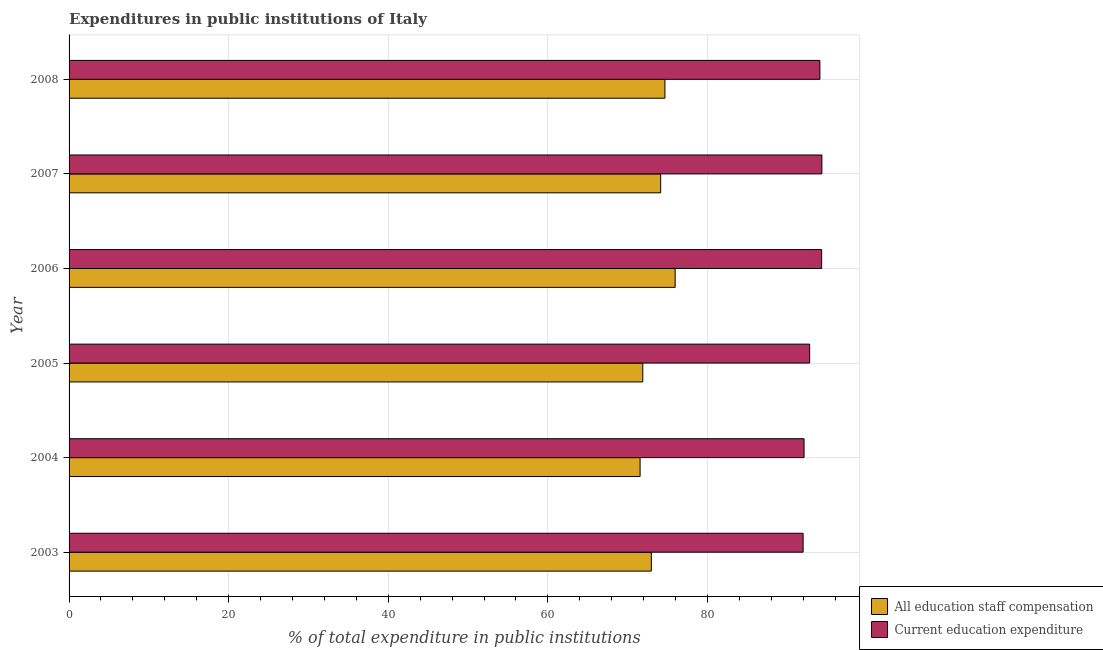How many groups of bars are there?
Offer a very short reply. 6. How many bars are there on the 2nd tick from the top?
Your answer should be very brief. 2. How many bars are there on the 5th tick from the bottom?
Provide a succinct answer. 2. What is the expenditure in education in 2003?
Keep it short and to the point. 91.98. Across all years, what is the maximum expenditure in staff compensation?
Your answer should be very brief. 75.95. Across all years, what is the minimum expenditure in staff compensation?
Your answer should be very brief. 71.56. In which year was the expenditure in education maximum?
Provide a short and direct response. 2007. In which year was the expenditure in staff compensation minimum?
Provide a short and direct response. 2004. What is the total expenditure in staff compensation in the graph?
Your response must be concise. 441.18. What is the difference between the expenditure in staff compensation in 2003 and that in 2004?
Offer a terse response. 1.41. What is the difference between the expenditure in education in 2004 and the expenditure in staff compensation in 2005?
Give a very brief answer. 20.21. What is the average expenditure in education per year?
Offer a very short reply. 93.27. In the year 2006, what is the difference between the expenditure in education and expenditure in staff compensation?
Make the answer very short. 18.36. In how many years, is the expenditure in education greater than 36 %?
Offer a very short reply. 6. What is the ratio of the expenditure in staff compensation in 2005 to that in 2007?
Offer a terse response. 0.97. Is the difference between the expenditure in education in 2004 and 2006 greater than the difference between the expenditure in staff compensation in 2004 and 2006?
Ensure brevity in your answer.  Yes. What is the difference between the highest and the second highest expenditure in education?
Provide a succinct answer. 0.03. What is the difference between the highest and the lowest expenditure in education?
Make the answer very short. 2.35. In how many years, is the expenditure in education greater than the average expenditure in education taken over all years?
Your answer should be very brief. 3. Is the sum of the expenditure in staff compensation in 2005 and 2007 greater than the maximum expenditure in education across all years?
Give a very brief answer. Yes. What does the 2nd bar from the top in 2006 represents?
Your answer should be very brief. All education staff compensation. What does the 2nd bar from the bottom in 2005 represents?
Keep it short and to the point. Current education expenditure. Does the graph contain any zero values?
Provide a short and direct response. No. How many legend labels are there?
Your answer should be very brief. 2. What is the title of the graph?
Keep it short and to the point. Expenditures in public institutions of Italy. Does "Pregnant women" appear as one of the legend labels in the graph?
Keep it short and to the point. No. What is the label or title of the X-axis?
Your answer should be compact. % of total expenditure in public institutions. What is the % of total expenditure in public institutions of All education staff compensation in 2003?
Give a very brief answer. 72.97. What is the % of total expenditure in public institutions in Current education expenditure in 2003?
Offer a terse response. 91.98. What is the % of total expenditure in public institutions in All education staff compensation in 2004?
Offer a terse response. 71.56. What is the % of total expenditure in public institutions of Current education expenditure in 2004?
Your answer should be compact. 92.1. What is the % of total expenditure in public institutions of All education staff compensation in 2005?
Offer a terse response. 71.9. What is the % of total expenditure in public institutions in Current education expenditure in 2005?
Provide a short and direct response. 92.81. What is the % of total expenditure in public institutions in All education staff compensation in 2006?
Make the answer very short. 75.95. What is the % of total expenditure in public institutions of Current education expenditure in 2006?
Offer a terse response. 94.31. What is the % of total expenditure in public institutions of All education staff compensation in 2007?
Provide a short and direct response. 74.14. What is the % of total expenditure in public institutions in Current education expenditure in 2007?
Keep it short and to the point. 94.34. What is the % of total expenditure in public institutions of All education staff compensation in 2008?
Give a very brief answer. 74.67. What is the % of total expenditure in public institutions in Current education expenditure in 2008?
Keep it short and to the point. 94.09. Across all years, what is the maximum % of total expenditure in public institutions in All education staff compensation?
Make the answer very short. 75.95. Across all years, what is the maximum % of total expenditure in public institutions in Current education expenditure?
Offer a terse response. 94.34. Across all years, what is the minimum % of total expenditure in public institutions in All education staff compensation?
Provide a short and direct response. 71.56. Across all years, what is the minimum % of total expenditure in public institutions of Current education expenditure?
Ensure brevity in your answer.  91.98. What is the total % of total expenditure in public institutions of All education staff compensation in the graph?
Provide a succinct answer. 441.18. What is the total % of total expenditure in public institutions in Current education expenditure in the graph?
Your answer should be very brief. 559.63. What is the difference between the % of total expenditure in public institutions of All education staff compensation in 2003 and that in 2004?
Keep it short and to the point. 1.41. What is the difference between the % of total expenditure in public institutions of Current education expenditure in 2003 and that in 2004?
Give a very brief answer. -0.12. What is the difference between the % of total expenditure in public institutions in All education staff compensation in 2003 and that in 2005?
Keep it short and to the point. 1.07. What is the difference between the % of total expenditure in public institutions of Current education expenditure in 2003 and that in 2005?
Give a very brief answer. -0.82. What is the difference between the % of total expenditure in public institutions of All education staff compensation in 2003 and that in 2006?
Your response must be concise. -2.98. What is the difference between the % of total expenditure in public institutions in Current education expenditure in 2003 and that in 2006?
Provide a short and direct response. -2.32. What is the difference between the % of total expenditure in public institutions of All education staff compensation in 2003 and that in 2007?
Give a very brief answer. -1.17. What is the difference between the % of total expenditure in public institutions in Current education expenditure in 2003 and that in 2007?
Provide a succinct answer. -2.35. What is the difference between the % of total expenditure in public institutions in All education staff compensation in 2003 and that in 2008?
Your answer should be very brief. -1.7. What is the difference between the % of total expenditure in public institutions in Current education expenditure in 2003 and that in 2008?
Offer a very short reply. -2.11. What is the difference between the % of total expenditure in public institutions in All education staff compensation in 2004 and that in 2005?
Your answer should be compact. -0.34. What is the difference between the % of total expenditure in public institutions in Current education expenditure in 2004 and that in 2005?
Your answer should be very brief. -0.7. What is the difference between the % of total expenditure in public institutions of All education staff compensation in 2004 and that in 2006?
Give a very brief answer. -4.39. What is the difference between the % of total expenditure in public institutions in Current education expenditure in 2004 and that in 2006?
Give a very brief answer. -2.2. What is the difference between the % of total expenditure in public institutions of All education staff compensation in 2004 and that in 2007?
Your answer should be very brief. -2.58. What is the difference between the % of total expenditure in public institutions in Current education expenditure in 2004 and that in 2007?
Make the answer very short. -2.23. What is the difference between the % of total expenditure in public institutions in All education staff compensation in 2004 and that in 2008?
Your response must be concise. -3.11. What is the difference between the % of total expenditure in public institutions of Current education expenditure in 2004 and that in 2008?
Offer a very short reply. -1.99. What is the difference between the % of total expenditure in public institutions of All education staff compensation in 2005 and that in 2006?
Keep it short and to the point. -4.06. What is the difference between the % of total expenditure in public institutions of Current education expenditure in 2005 and that in 2006?
Keep it short and to the point. -1.5. What is the difference between the % of total expenditure in public institutions in All education staff compensation in 2005 and that in 2007?
Your response must be concise. -2.24. What is the difference between the % of total expenditure in public institutions of Current education expenditure in 2005 and that in 2007?
Keep it short and to the point. -1.53. What is the difference between the % of total expenditure in public institutions in All education staff compensation in 2005 and that in 2008?
Your response must be concise. -2.77. What is the difference between the % of total expenditure in public institutions in Current education expenditure in 2005 and that in 2008?
Offer a terse response. -1.28. What is the difference between the % of total expenditure in public institutions in All education staff compensation in 2006 and that in 2007?
Offer a very short reply. 1.81. What is the difference between the % of total expenditure in public institutions of Current education expenditure in 2006 and that in 2007?
Your response must be concise. -0.03. What is the difference between the % of total expenditure in public institutions in All education staff compensation in 2006 and that in 2008?
Keep it short and to the point. 1.28. What is the difference between the % of total expenditure in public institutions of Current education expenditure in 2006 and that in 2008?
Provide a short and direct response. 0.22. What is the difference between the % of total expenditure in public institutions in All education staff compensation in 2007 and that in 2008?
Provide a short and direct response. -0.53. What is the difference between the % of total expenditure in public institutions in Current education expenditure in 2007 and that in 2008?
Give a very brief answer. 0.25. What is the difference between the % of total expenditure in public institutions of All education staff compensation in 2003 and the % of total expenditure in public institutions of Current education expenditure in 2004?
Provide a succinct answer. -19.14. What is the difference between the % of total expenditure in public institutions of All education staff compensation in 2003 and the % of total expenditure in public institutions of Current education expenditure in 2005?
Ensure brevity in your answer.  -19.84. What is the difference between the % of total expenditure in public institutions of All education staff compensation in 2003 and the % of total expenditure in public institutions of Current education expenditure in 2006?
Give a very brief answer. -21.34. What is the difference between the % of total expenditure in public institutions of All education staff compensation in 2003 and the % of total expenditure in public institutions of Current education expenditure in 2007?
Provide a succinct answer. -21.37. What is the difference between the % of total expenditure in public institutions in All education staff compensation in 2003 and the % of total expenditure in public institutions in Current education expenditure in 2008?
Provide a succinct answer. -21.12. What is the difference between the % of total expenditure in public institutions of All education staff compensation in 2004 and the % of total expenditure in public institutions of Current education expenditure in 2005?
Your response must be concise. -21.25. What is the difference between the % of total expenditure in public institutions in All education staff compensation in 2004 and the % of total expenditure in public institutions in Current education expenditure in 2006?
Offer a very short reply. -22.75. What is the difference between the % of total expenditure in public institutions of All education staff compensation in 2004 and the % of total expenditure in public institutions of Current education expenditure in 2007?
Give a very brief answer. -22.78. What is the difference between the % of total expenditure in public institutions in All education staff compensation in 2004 and the % of total expenditure in public institutions in Current education expenditure in 2008?
Offer a terse response. -22.53. What is the difference between the % of total expenditure in public institutions of All education staff compensation in 2005 and the % of total expenditure in public institutions of Current education expenditure in 2006?
Your answer should be very brief. -22.41. What is the difference between the % of total expenditure in public institutions of All education staff compensation in 2005 and the % of total expenditure in public institutions of Current education expenditure in 2007?
Give a very brief answer. -22.44. What is the difference between the % of total expenditure in public institutions in All education staff compensation in 2005 and the % of total expenditure in public institutions in Current education expenditure in 2008?
Your response must be concise. -22.19. What is the difference between the % of total expenditure in public institutions in All education staff compensation in 2006 and the % of total expenditure in public institutions in Current education expenditure in 2007?
Your answer should be compact. -18.39. What is the difference between the % of total expenditure in public institutions of All education staff compensation in 2006 and the % of total expenditure in public institutions of Current education expenditure in 2008?
Your answer should be compact. -18.14. What is the difference between the % of total expenditure in public institutions in All education staff compensation in 2007 and the % of total expenditure in public institutions in Current education expenditure in 2008?
Your answer should be very brief. -19.95. What is the average % of total expenditure in public institutions of All education staff compensation per year?
Provide a succinct answer. 73.53. What is the average % of total expenditure in public institutions in Current education expenditure per year?
Your response must be concise. 93.27. In the year 2003, what is the difference between the % of total expenditure in public institutions in All education staff compensation and % of total expenditure in public institutions in Current education expenditure?
Make the answer very short. -19.02. In the year 2004, what is the difference between the % of total expenditure in public institutions of All education staff compensation and % of total expenditure in public institutions of Current education expenditure?
Ensure brevity in your answer.  -20.55. In the year 2005, what is the difference between the % of total expenditure in public institutions in All education staff compensation and % of total expenditure in public institutions in Current education expenditure?
Give a very brief answer. -20.91. In the year 2006, what is the difference between the % of total expenditure in public institutions of All education staff compensation and % of total expenditure in public institutions of Current education expenditure?
Provide a succinct answer. -18.36. In the year 2007, what is the difference between the % of total expenditure in public institutions in All education staff compensation and % of total expenditure in public institutions in Current education expenditure?
Provide a succinct answer. -20.2. In the year 2008, what is the difference between the % of total expenditure in public institutions in All education staff compensation and % of total expenditure in public institutions in Current education expenditure?
Your response must be concise. -19.42. What is the ratio of the % of total expenditure in public institutions of All education staff compensation in 2003 to that in 2004?
Keep it short and to the point. 1.02. What is the ratio of the % of total expenditure in public institutions in All education staff compensation in 2003 to that in 2005?
Provide a succinct answer. 1.01. What is the ratio of the % of total expenditure in public institutions of Current education expenditure in 2003 to that in 2005?
Provide a short and direct response. 0.99. What is the ratio of the % of total expenditure in public institutions in All education staff compensation in 2003 to that in 2006?
Give a very brief answer. 0.96. What is the ratio of the % of total expenditure in public institutions in Current education expenditure in 2003 to that in 2006?
Provide a succinct answer. 0.98. What is the ratio of the % of total expenditure in public institutions in All education staff compensation in 2003 to that in 2007?
Make the answer very short. 0.98. What is the ratio of the % of total expenditure in public institutions of Current education expenditure in 2003 to that in 2007?
Offer a very short reply. 0.98. What is the ratio of the % of total expenditure in public institutions of All education staff compensation in 2003 to that in 2008?
Give a very brief answer. 0.98. What is the ratio of the % of total expenditure in public institutions in Current education expenditure in 2003 to that in 2008?
Give a very brief answer. 0.98. What is the ratio of the % of total expenditure in public institutions in Current education expenditure in 2004 to that in 2005?
Offer a very short reply. 0.99. What is the ratio of the % of total expenditure in public institutions of All education staff compensation in 2004 to that in 2006?
Your response must be concise. 0.94. What is the ratio of the % of total expenditure in public institutions in Current education expenditure in 2004 to that in 2006?
Make the answer very short. 0.98. What is the ratio of the % of total expenditure in public institutions in All education staff compensation in 2004 to that in 2007?
Your answer should be compact. 0.97. What is the ratio of the % of total expenditure in public institutions of Current education expenditure in 2004 to that in 2007?
Your answer should be very brief. 0.98. What is the ratio of the % of total expenditure in public institutions of Current education expenditure in 2004 to that in 2008?
Make the answer very short. 0.98. What is the ratio of the % of total expenditure in public institutions of All education staff compensation in 2005 to that in 2006?
Offer a terse response. 0.95. What is the ratio of the % of total expenditure in public institutions in Current education expenditure in 2005 to that in 2006?
Offer a very short reply. 0.98. What is the ratio of the % of total expenditure in public institutions of All education staff compensation in 2005 to that in 2007?
Offer a very short reply. 0.97. What is the ratio of the % of total expenditure in public institutions in Current education expenditure in 2005 to that in 2007?
Make the answer very short. 0.98. What is the ratio of the % of total expenditure in public institutions in All education staff compensation in 2005 to that in 2008?
Offer a very short reply. 0.96. What is the ratio of the % of total expenditure in public institutions of Current education expenditure in 2005 to that in 2008?
Your answer should be very brief. 0.99. What is the ratio of the % of total expenditure in public institutions in All education staff compensation in 2006 to that in 2007?
Your response must be concise. 1.02. What is the ratio of the % of total expenditure in public institutions of Current education expenditure in 2006 to that in 2007?
Offer a terse response. 1. What is the ratio of the % of total expenditure in public institutions in All education staff compensation in 2006 to that in 2008?
Give a very brief answer. 1.02. What is the ratio of the % of total expenditure in public institutions of Current education expenditure in 2007 to that in 2008?
Your answer should be compact. 1. What is the difference between the highest and the second highest % of total expenditure in public institutions in All education staff compensation?
Ensure brevity in your answer.  1.28. What is the difference between the highest and the second highest % of total expenditure in public institutions in Current education expenditure?
Provide a short and direct response. 0.03. What is the difference between the highest and the lowest % of total expenditure in public institutions of All education staff compensation?
Make the answer very short. 4.39. What is the difference between the highest and the lowest % of total expenditure in public institutions in Current education expenditure?
Offer a terse response. 2.35. 